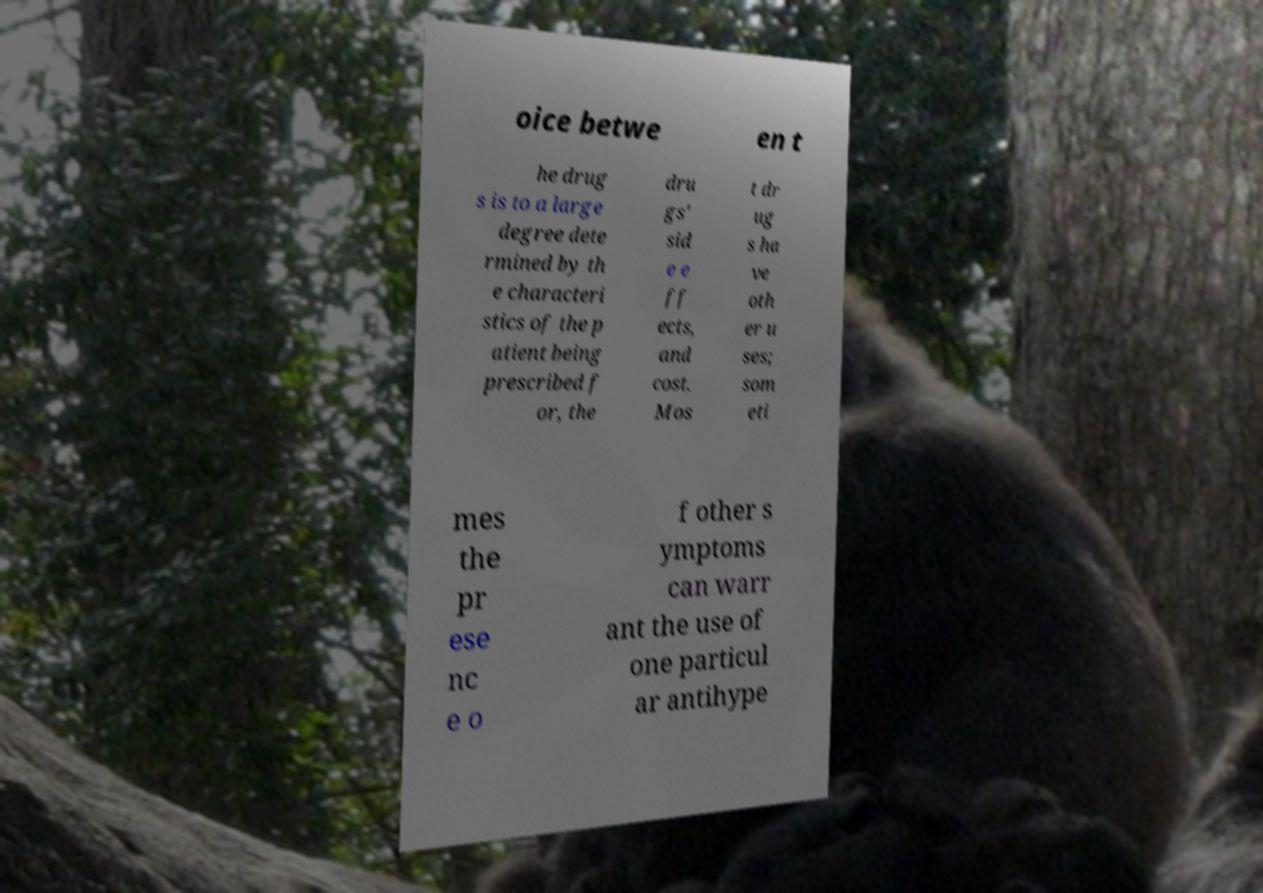Can you accurately transcribe the text from the provided image for me? oice betwe en t he drug s is to a large degree dete rmined by th e characteri stics of the p atient being prescribed f or, the dru gs' sid e e ff ects, and cost. Mos t dr ug s ha ve oth er u ses; som eti mes the pr ese nc e o f other s ymptoms can warr ant the use of one particul ar antihype 